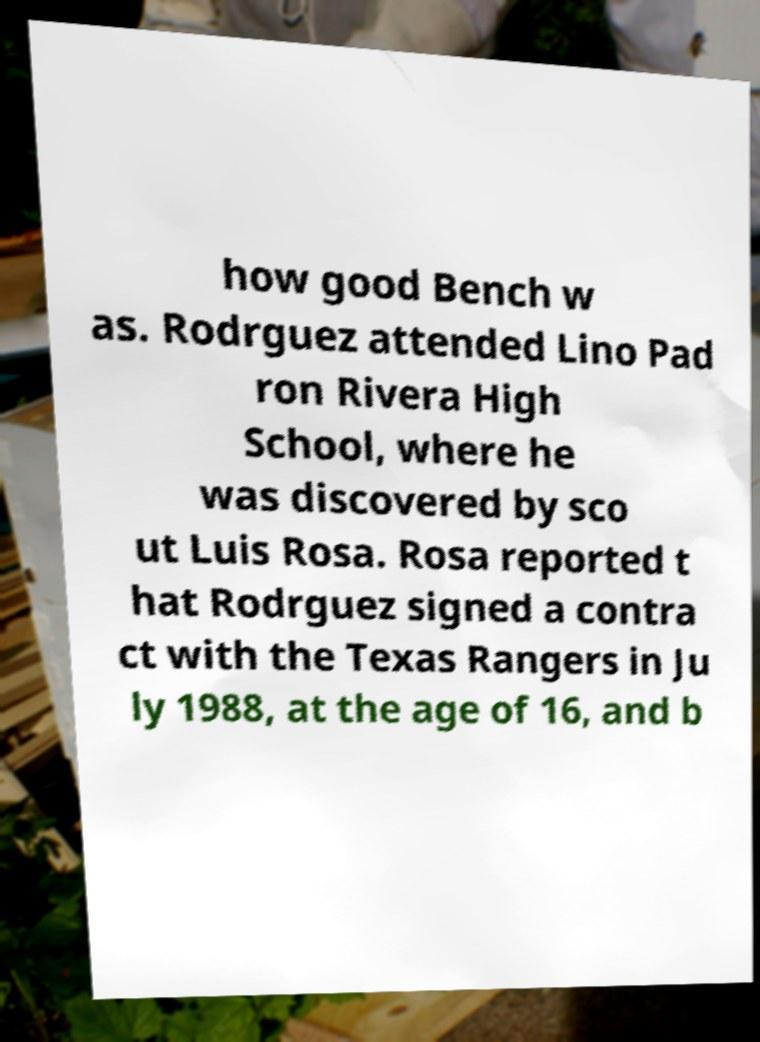Could you extract and type out the text from this image? how good Bench w as. Rodrguez attended Lino Pad ron Rivera High School, where he was discovered by sco ut Luis Rosa. Rosa reported t hat Rodrguez signed a contra ct with the Texas Rangers in Ju ly 1988, at the age of 16, and b 